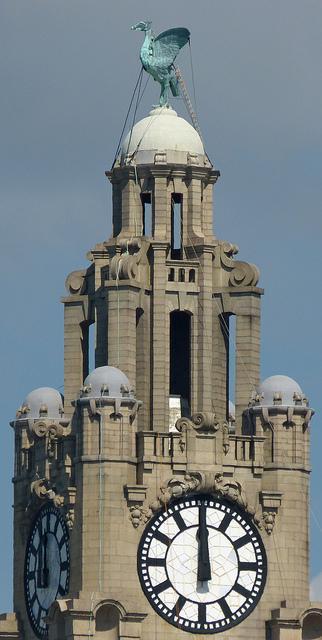How many Roman numerals are on the clock?
Give a very brief answer. 12. How many clocks are visible?
Give a very brief answer. 2. 